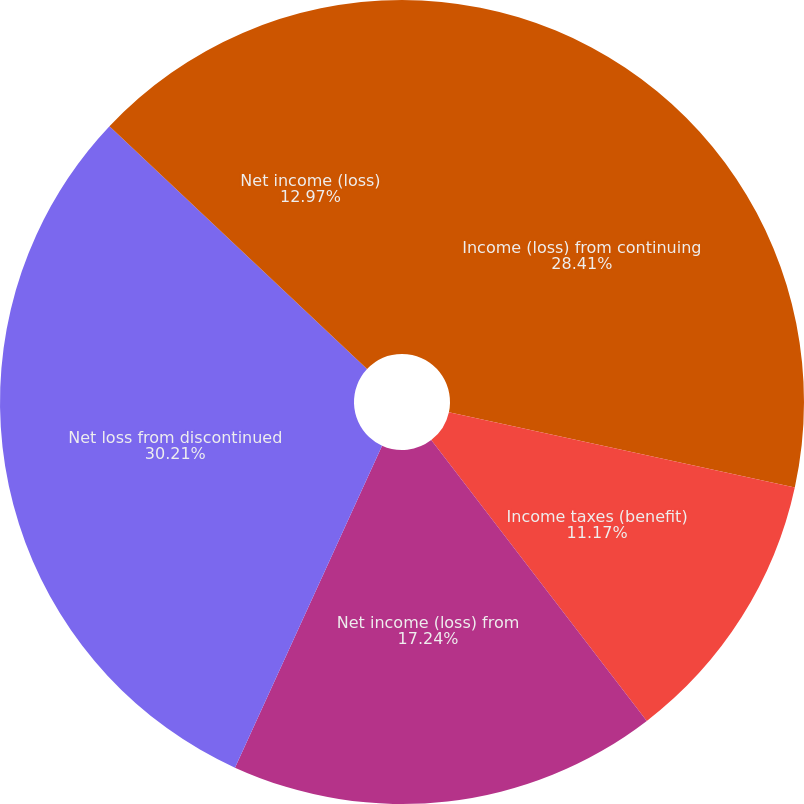<chart> <loc_0><loc_0><loc_500><loc_500><pie_chart><fcel>Income (loss) from continuing<fcel>Income taxes (benefit)<fcel>Net income (loss) from<fcel>Net loss from discontinued<fcel>Net income (loss)<nl><fcel>28.41%<fcel>11.17%<fcel>17.24%<fcel>30.21%<fcel>12.97%<nl></chart> 